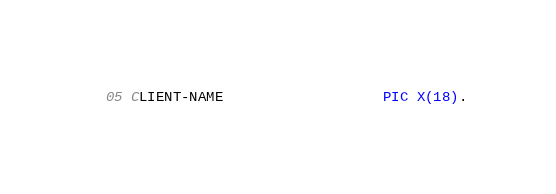Convert code to text. <code><loc_0><loc_0><loc_500><loc_500><_COBOL_>  05 CLIENT-NAME                   PIC X(18).
</code> 